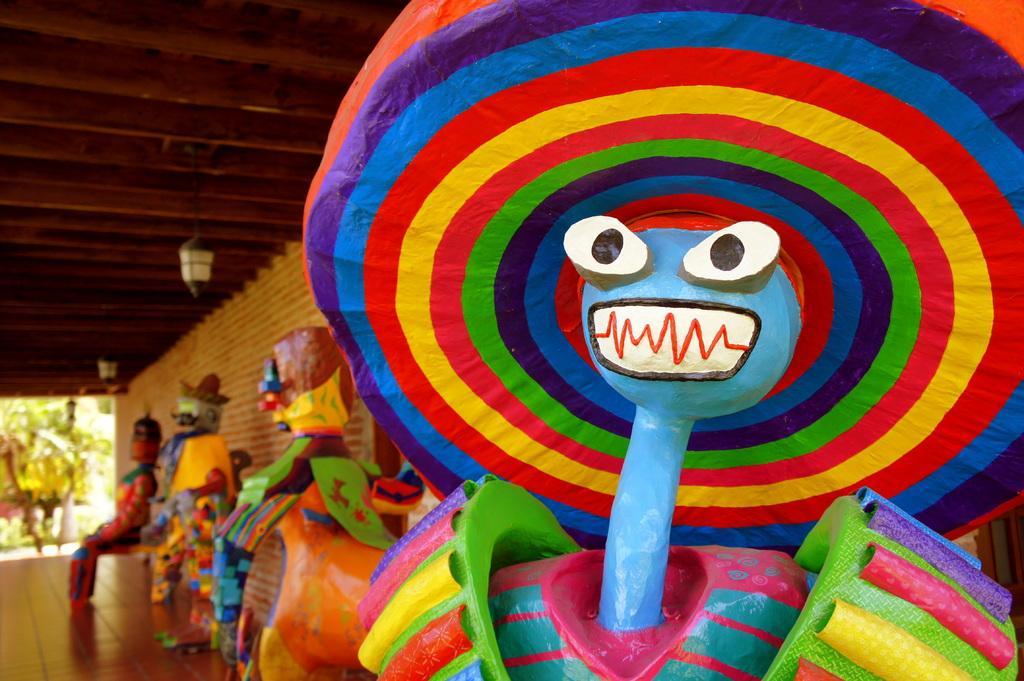Please provide a concise description of this image. In this image we can see some colorful things which are placed on floor are in different shapes and in the background of the image there is a wall and top of the image there is roof and some lamps. 